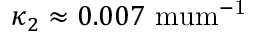<formula> <loc_0><loc_0><loc_500><loc_500>\kappa _ { 2 } \approx 0 . 0 0 7 \ m u m ^ { - 1 }</formula> 